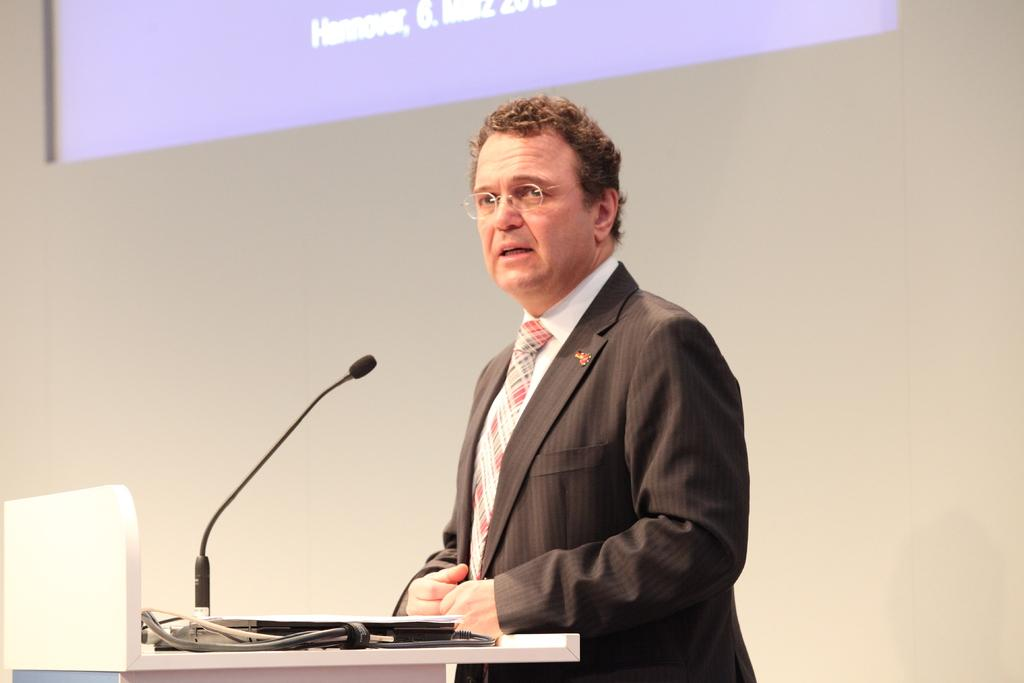Who is the main subject in the image? There is a man in the image. What is the man doing in the image? The man is standing at a podium and speaking with the help of a microphone. What can be seen on the wall in the image? There is a projection light on the wall. What accessory is the man wearing in the image? The man is wearing spectacles. What type of door can be seen in the image? There is no door present in the image. Can you tell me how many airplanes are visible in the image? There are no airplanes visible in the image. 